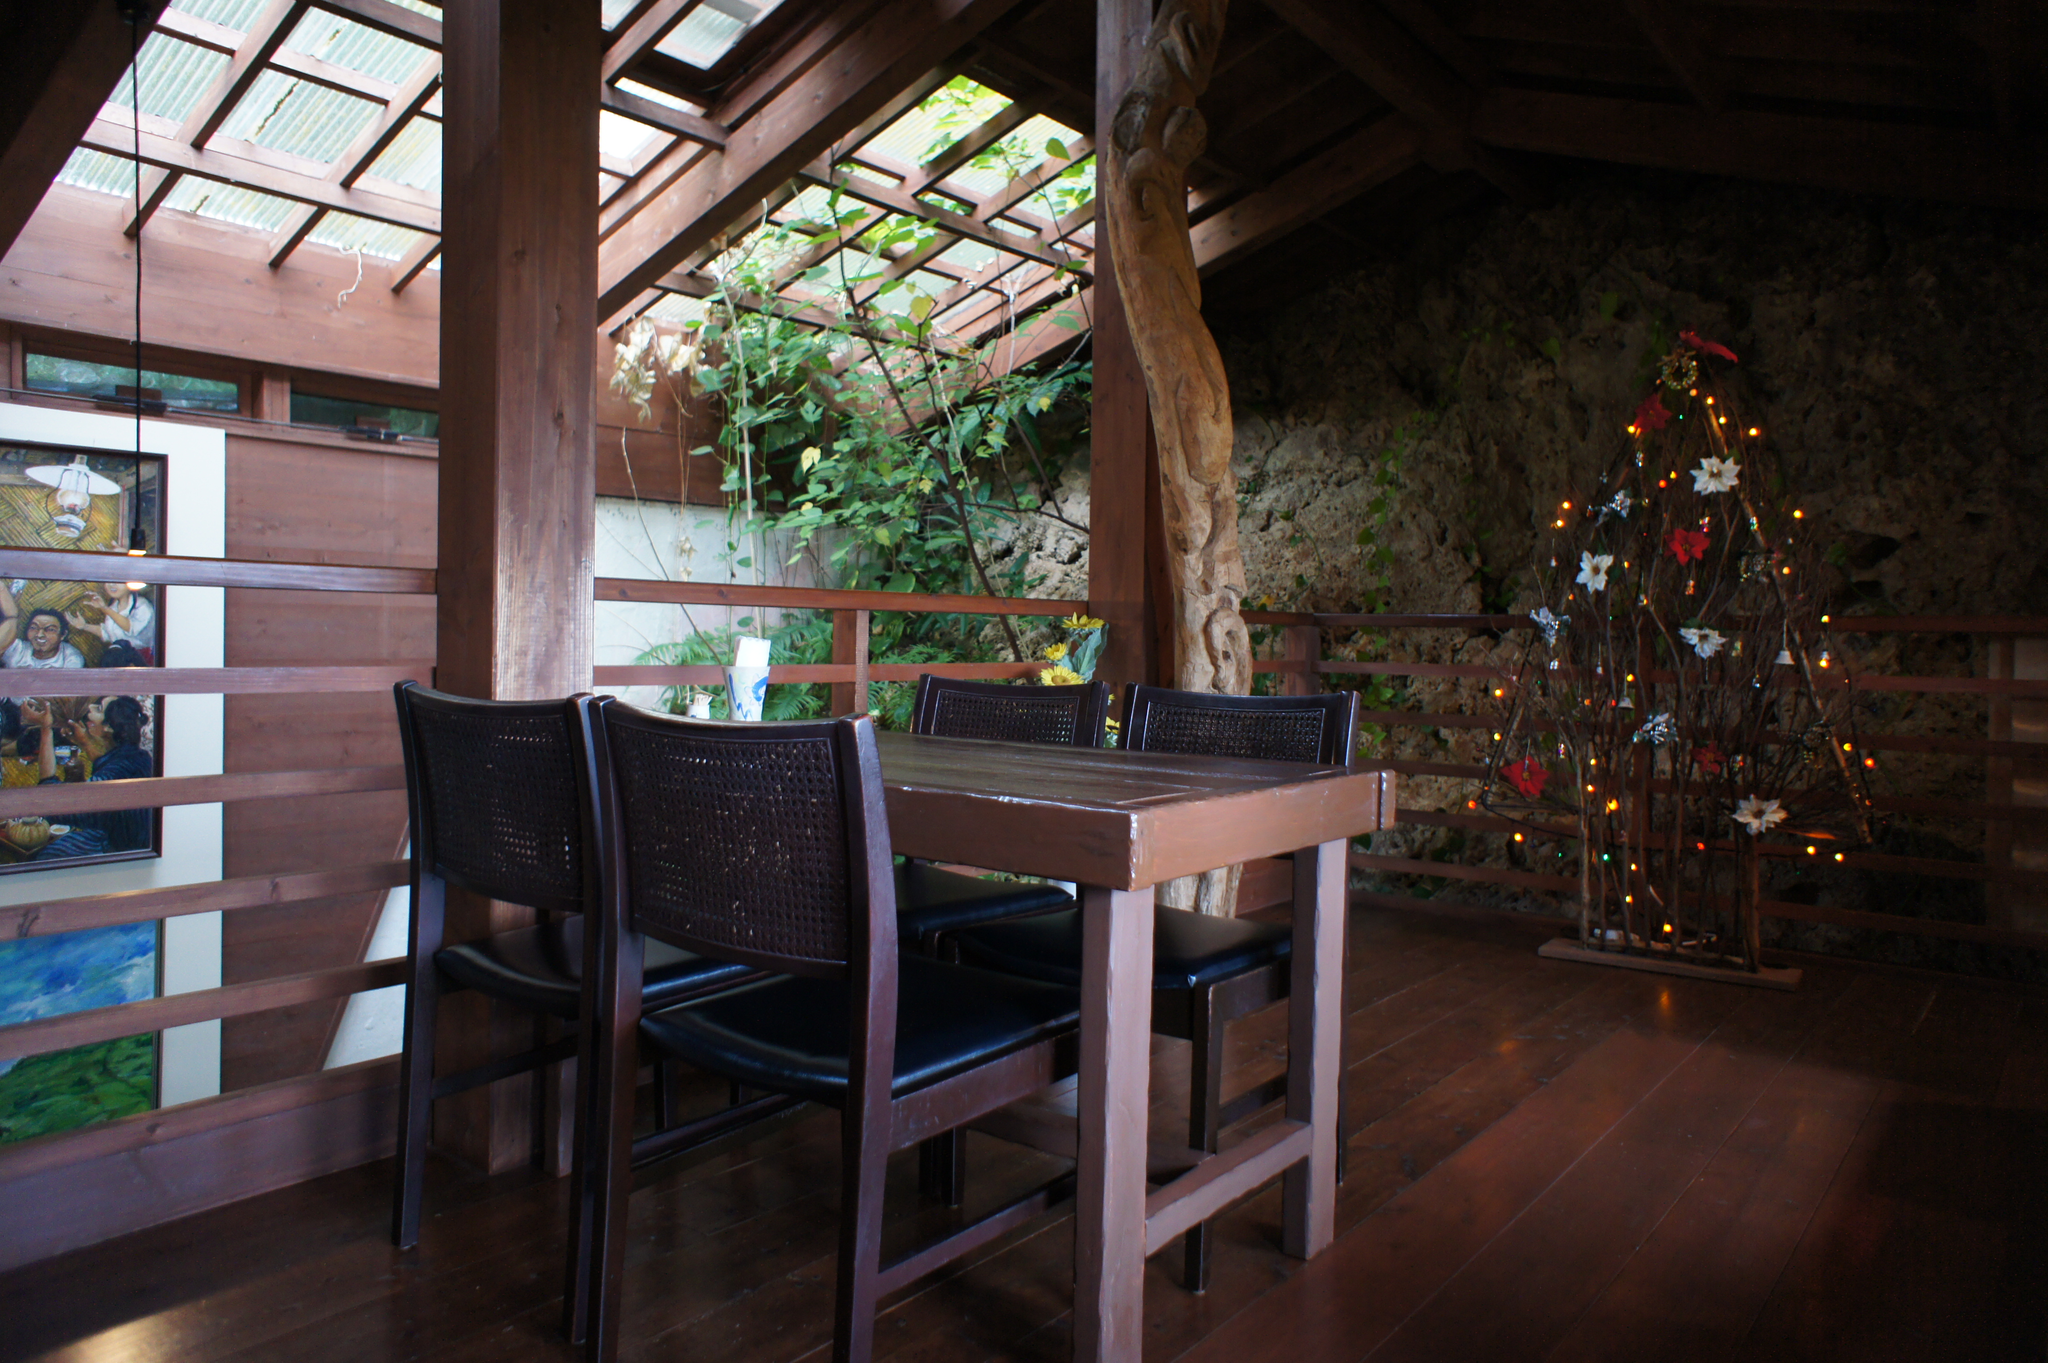Can you describe this image briefly? In this image we can see there is a house. And there is a table and chairs. At the side there is a wall with photo frame. And there are decorative items, trees and fence. 